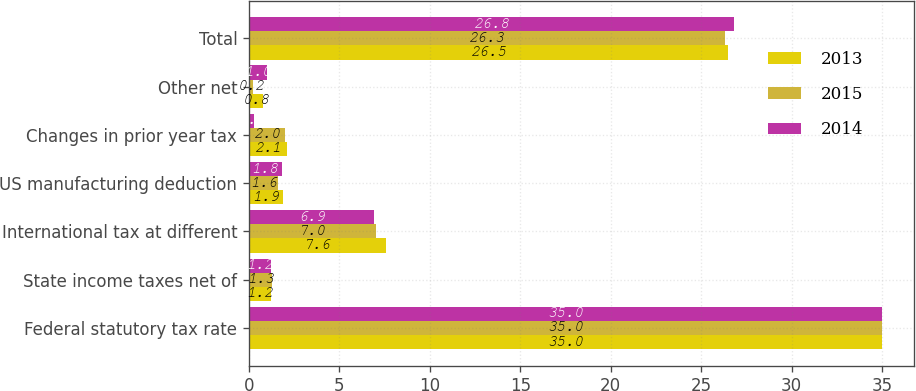Convert chart. <chart><loc_0><loc_0><loc_500><loc_500><stacked_bar_chart><ecel><fcel>Federal statutory tax rate<fcel>State income taxes net of<fcel>International tax at different<fcel>US manufacturing deduction<fcel>Changes in prior year tax<fcel>Other net<fcel>Total<nl><fcel>2013<fcel>35<fcel>1.2<fcel>7.6<fcel>1.9<fcel>2.1<fcel>0.8<fcel>26.5<nl><fcel>2015<fcel>35<fcel>1.3<fcel>7<fcel>1.6<fcel>2<fcel>0.2<fcel>26.3<nl><fcel>2014<fcel>35<fcel>1.2<fcel>6.9<fcel>1.8<fcel>0.3<fcel>1<fcel>26.8<nl></chart> 